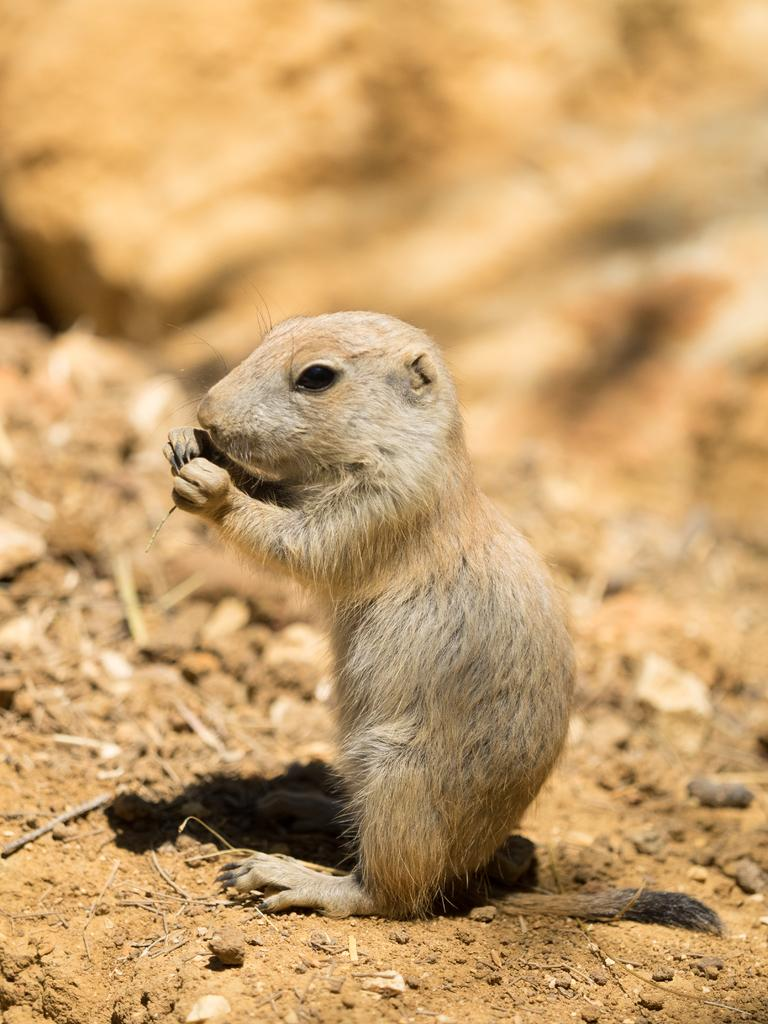What animal is present in the image? There is a gopher in the image. Where is the gopher located? The gopher is sitting in the sand. What else can be seen on the ground in the image? There are stones on the ground in the image. What type of goose is interacting with the gopher in the image? There is no goose present in the image; it only features a gopher sitting in the sand. 